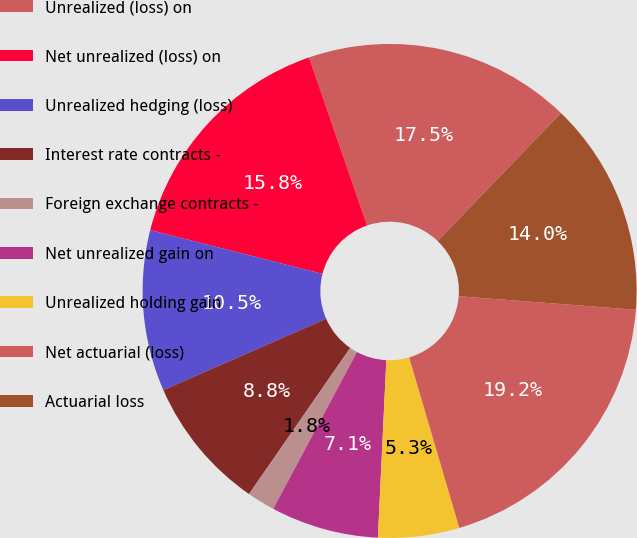Convert chart to OTSL. <chart><loc_0><loc_0><loc_500><loc_500><pie_chart><fcel>Unrealized (loss) on<fcel>Net unrealized (loss) on<fcel>Unrealized hedging (loss)<fcel>Interest rate contracts -<fcel>Foreign exchange contracts -<fcel>Net unrealized gain on<fcel>Unrealized holding gain<fcel>Net actuarial (loss)<fcel>Actuarial loss<nl><fcel>17.49%<fcel>15.75%<fcel>10.53%<fcel>8.79%<fcel>1.83%<fcel>7.05%<fcel>5.31%<fcel>19.23%<fcel>14.01%<nl></chart> 